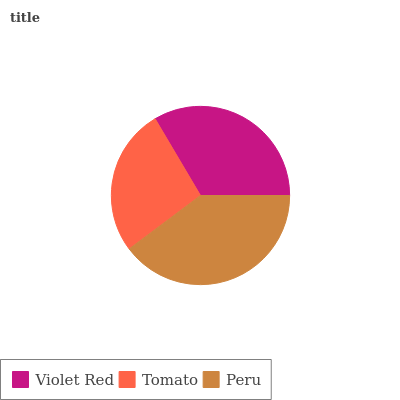Is Tomato the minimum?
Answer yes or no. Yes. Is Peru the maximum?
Answer yes or no. Yes. Is Peru the minimum?
Answer yes or no. No. Is Tomato the maximum?
Answer yes or no. No. Is Peru greater than Tomato?
Answer yes or no. Yes. Is Tomato less than Peru?
Answer yes or no. Yes. Is Tomato greater than Peru?
Answer yes or no. No. Is Peru less than Tomato?
Answer yes or no. No. Is Violet Red the high median?
Answer yes or no. Yes. Is Violet Red the low median?
Answer yes or no. Yes. Is Tomato the high median?
Answer yes or no. No. Is Tomato the low median?
Answer yes or no. No. 